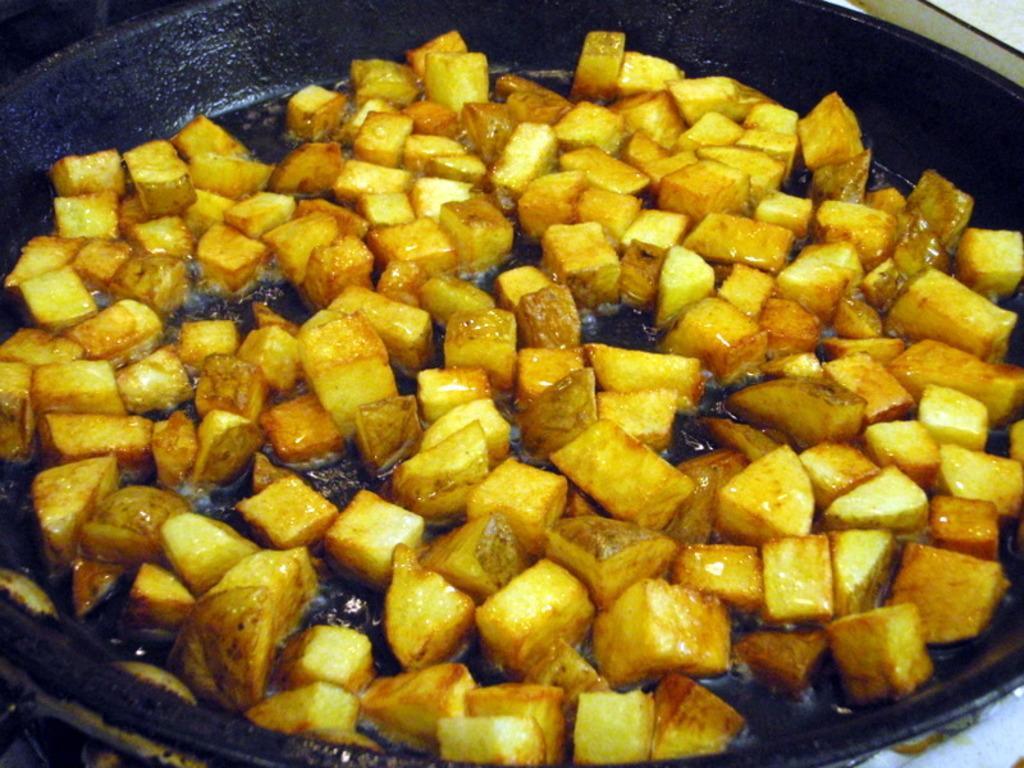Can you describe this image briefly? In this picture we can see a frying pan and on the pan there is the food and oil. 